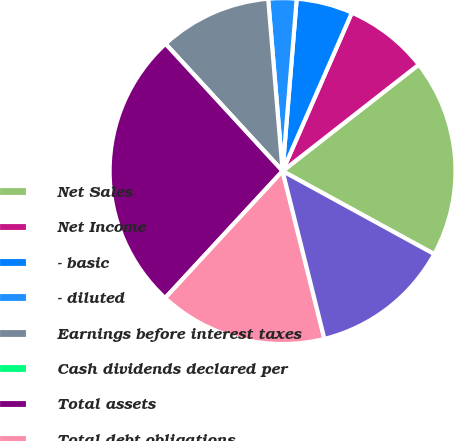<chart> <loc_0><loc_0><loc_500><loc_500><pie_chart><fcel>Net Sales<fcel>Net Income<fcel>- basic<fcel>- diluted<fcel>Earnings before interest taxes<fcel>Cash dividends declared per<fcel>Total assets<fcel>Total debt obligations<fcel>Stockholders' equity<nl><fcel>18.53%<fcel>7.88%<fcel>5.26%<fcel>2.63%<fcel>10.51%<fcel>0.0%<fcel>26.28%<fcel>15.77%<fcel>13.14%<nl></chart> 